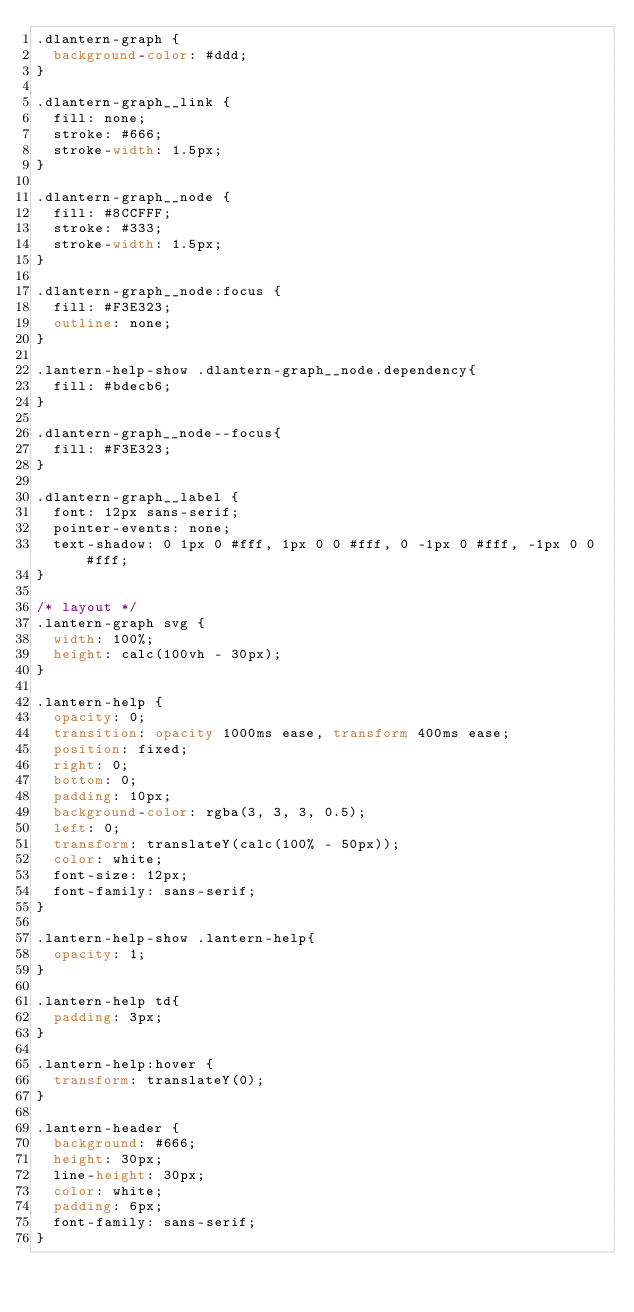Convert code to text. <code><loc_0><loc_0><loc_500><loc_500><_CSS_>.dlantern-graph {
  background-color: #ddd;
}

.dlantern-graph__link {
  fill: none;
  stroke: #666;
  stroke-width: 1.5px;
}

.dlantern-graph__node {
  fill: #8CCFFF;
  stroke: #333;
  stroke-width: 1.5px;
}

.dlantern-graph__node:focus {
  fill: #F3E323;
  outline: none;
}

.lantern-help-show .dlantern-graph__node.dependency{
  fill: #bdecb6;
}

.dlantern-graph__node--focus{
  fill: #F3E323;
}

.dlantern-graph__label {
  font: 12px sans-serif;
  pointer-events: none;
  text-shadow: 0 1px 0 #fff, 1px 0 0 #fff, 0 -1px 0 #fff, -1px 0 0 #fff;
}

/* layout */
.lantern-graph svg {
  width: 100%;
  height: calc(100vh - 30px);
}

.lantern-help {
  opacity: 0;
  transition: opacity 1000ms ease, transform 400ms ease;
  position: fixed;
  right: 0;
  bottom: 0;
  padding: 10px;
  background-color: rgba(3, 3, 3, 0.5);
  left: 0;
  transform: translateY(calc(100% - 50px));
  color: white;
  font-size: 12px;
  font-family: sans-serif;
}

.lantern-help-show .lantern-help{
  opacity: 1;
}

.lantern-help td{
  padding: 3px;
}

.lantern-help:hover {
  transform: translateY(0);
}

.lantern-header {
  background: #666;
  height: 30px;
  line-height: 30px;
  color: white;
  padding: 6px;
  font-family: sans-serif;
}
</code> 